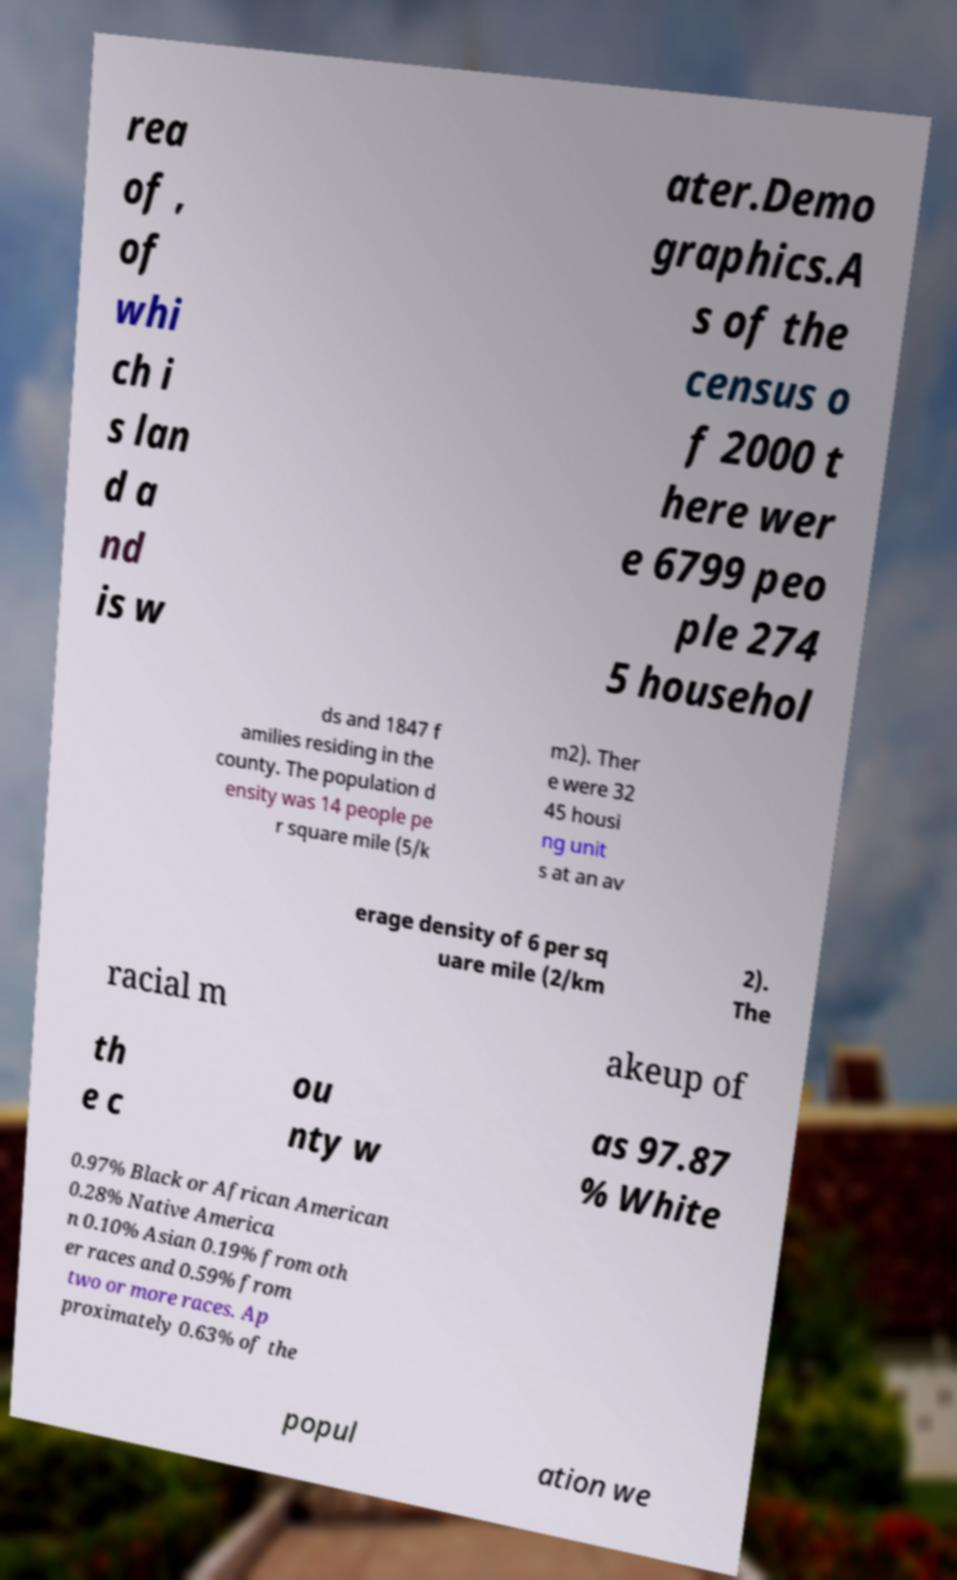Could you extract and type out the text from this image? rea of , of whi ch i s lan d a nd is w ater.Demo graphics.A s of the census o f 2000 t here wer e 6799 peo ple 274 5 househol ds and 1847 f amilies residing in the county. The population d ensity was 14 people pe r square mile (5/k m2). Ther e were 32 45 housi ng unit s at an av erage density of 6 per sq uare mile (2/km 2). The racial m akeup of th e c ou nty w as 97.87 % White 0.97% Black or African American 0.28% Native America n 0.10% Asian 0.19% from oth er races and 0.59% from two or more races. Ap proximately 0.63% of the popul ation we 